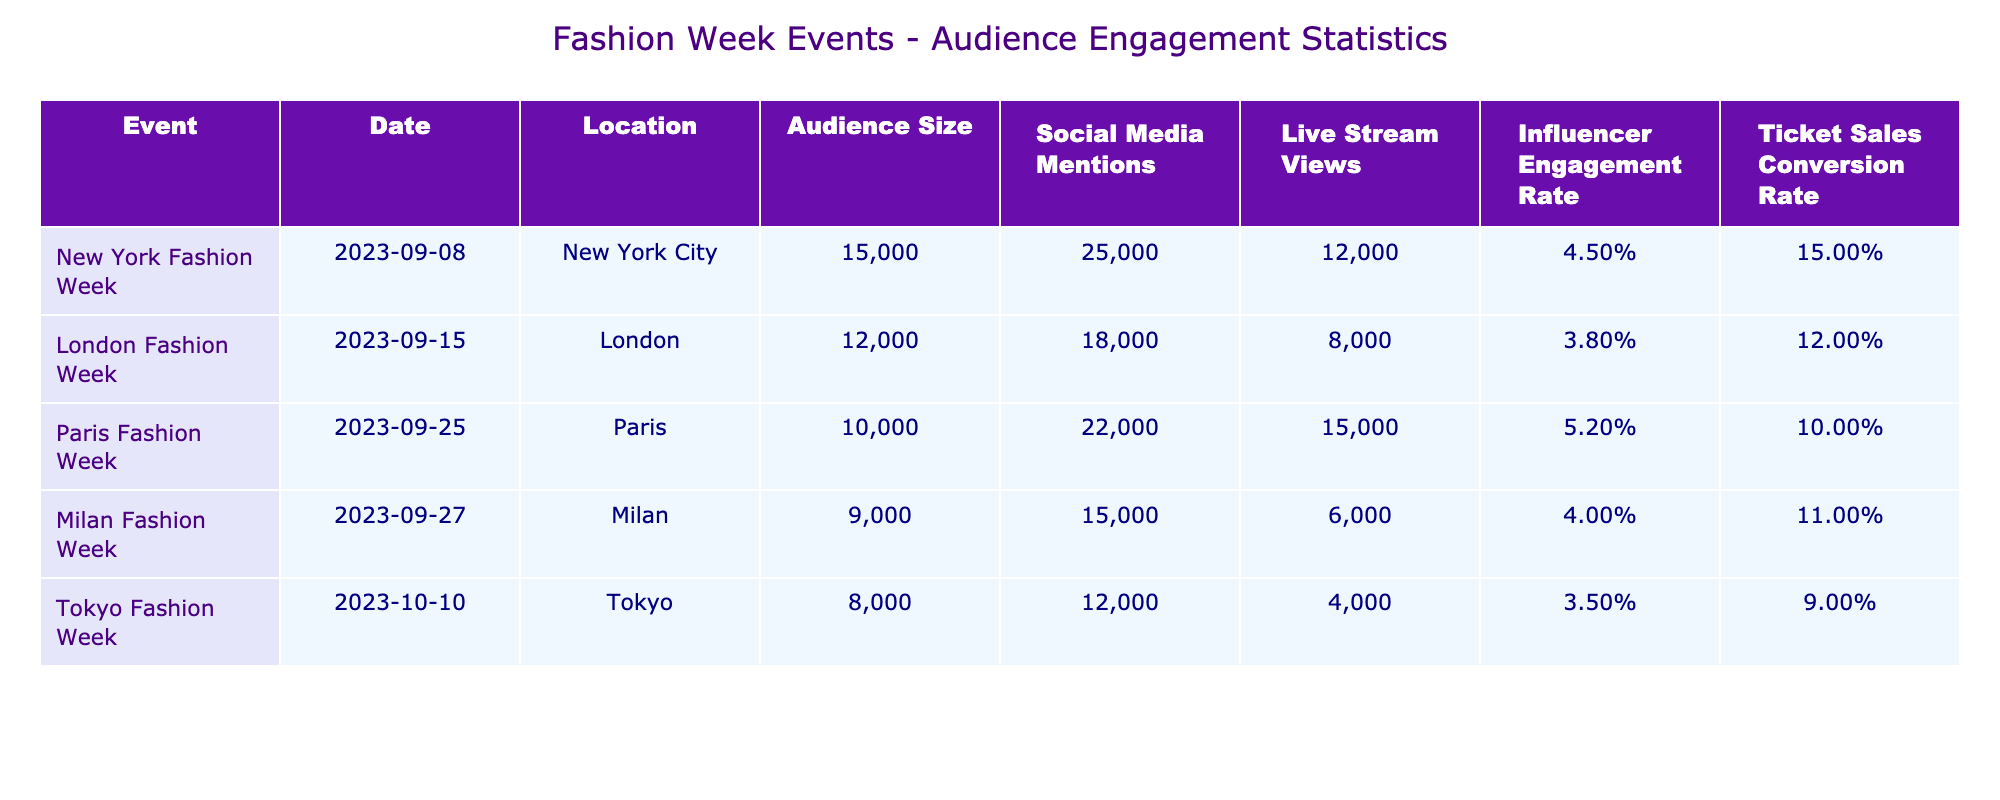What is the audience size for Paris Fashion Week? The table shows the audience size for each event. Looking under the "Audience Size" column for Paris Fashion Week, we find the value is 10,000.
Answer: 10,000 Which fashion week event had the highest influencer engagement rate? The "Influencer Engagement Rate" column lists the rates for each event. Paris Fashion Week has the highest percentage at 5.2%.
Answer: 5.2% What is the average ticket sales conversion rate across all events? We sum the ticket sales conversion rates: 15% + 12% + 10% + 11% + 9% = 57%. There are 5 events, so the average is 57% / 5 = 11.4%.
Answer: 11.4% Did the Tokyo Fashion Week have more social media mentions than London Fashion Week? Comparing the "Social Media Mentions" for Tokyo (12,000) and London (18,000), Tokyo has fewer mentions.
Answer: No What is the total audience size for New York and Milan Fashion Weeks combined? To find the combined size, we add the audience sizes: New York (15,000) + Milan (9,000) = 24,000.
Answer: 24,000 Is the live stream views count for Milan Fashion Week greater than the ticket sales conversion rate for that event? Milan Fashion Week's live stream views are 6,000, which is higher than its ticket sales conversion rate of 11% (which is a percentage, not a direct count). Thus, this is a valid comparison, focusing on the absolute numbers instead of percentages.
Answer: Yes Which city hosted the event with the lowest audience size? The "Audience Size" column shows that Tokyo Fashion Week had the lowest audience size at 8,000.
Answer: Tokyo What is the difference in social media mentions between New York and Paris Fashion Weeks? The social media mentions for New York are 25,000, and for Paris are 22,000. The difference is 25,000 - 22,000 = 3,000.
Answer: 3,000 How many more live stream views did Paris Fashion Week receive compared to Milan Fashion Week? Paris had 15,000 live stream views and Milan had 6,000. The difference is 15,000 - 6,000 = 9,000 live stream views.
Answer: 9,000 